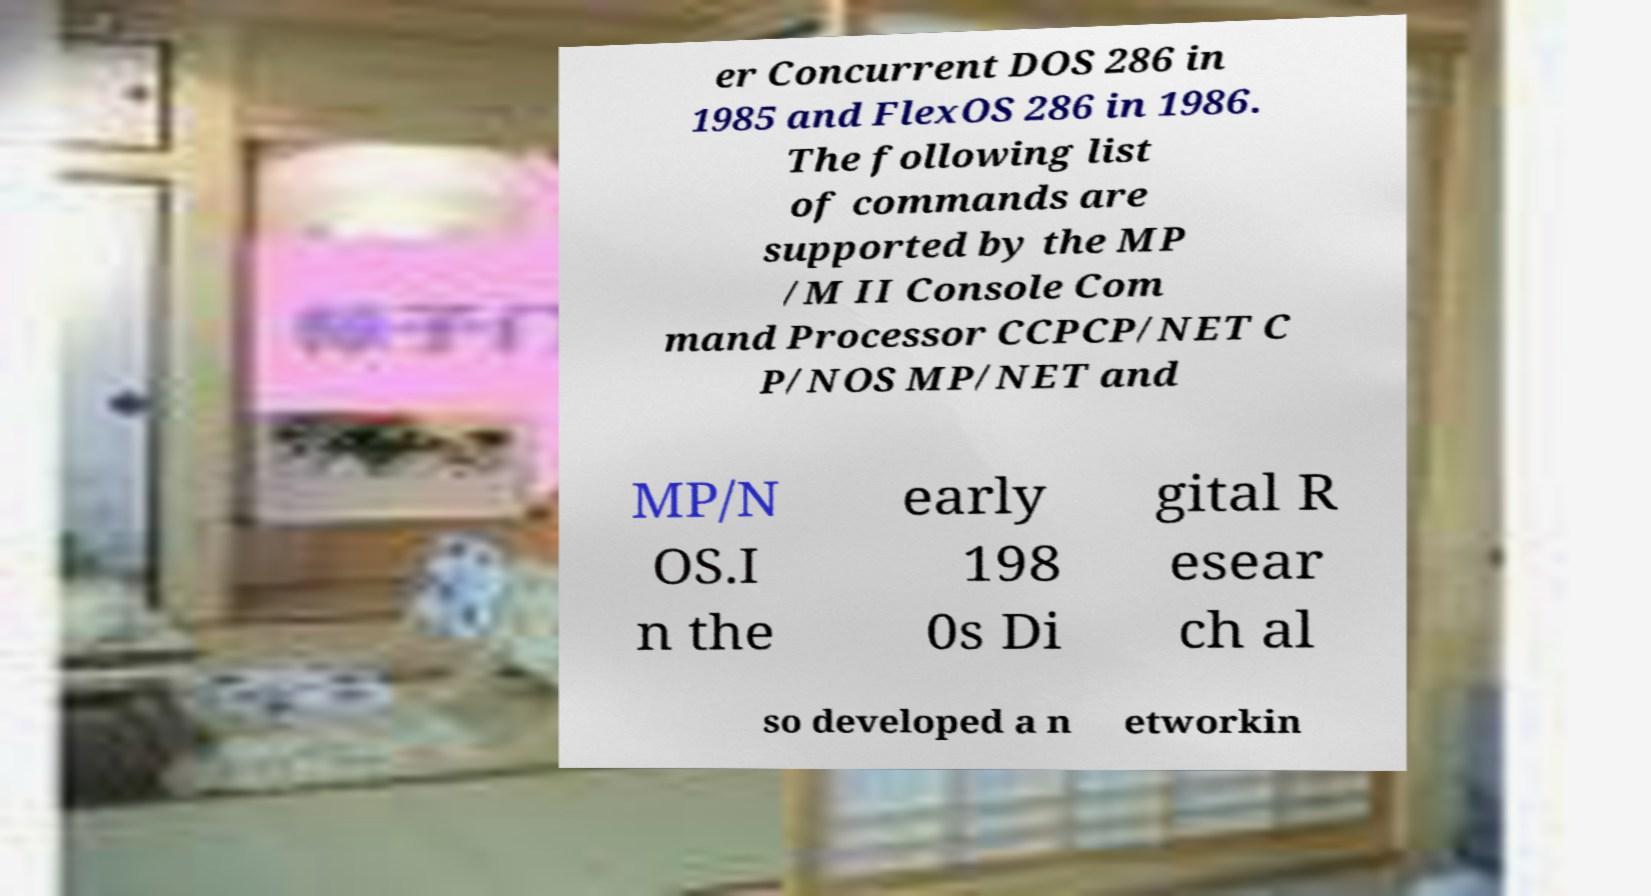For documentation purposes, I need the text within this image transcribed. Could you provide that? er Concurrent DOS 286 in 1985 and FlexOS 286 in 1986. The following list of commands are supported by the MP /M II Console Com mand Processor CCPCP/NET C P/NOS MP/NET and MP/N OS.I n the early 198 0s Di gital R esear ch al so developed a n etworkin 